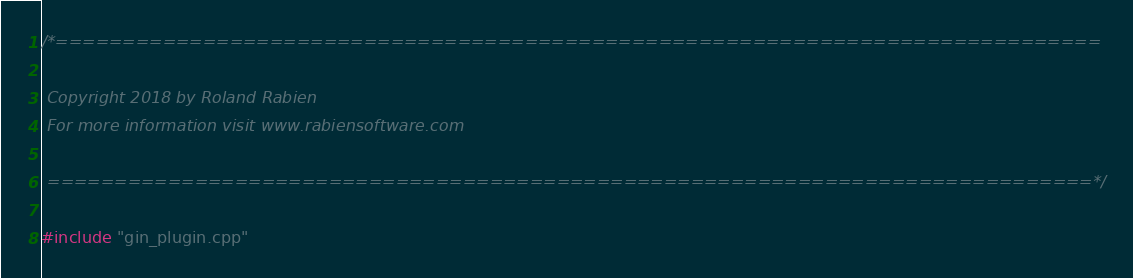<code> <loc_0><loc_0><loc_500><loc_500><_ObjectiveC_>/*==============================================================================

 Copyright 2018 by Roland Rabien
 For more information visit www.rabiensoftware.com

 ==============================================================================*/

#include "gin_plugin.cpp"

</code> 